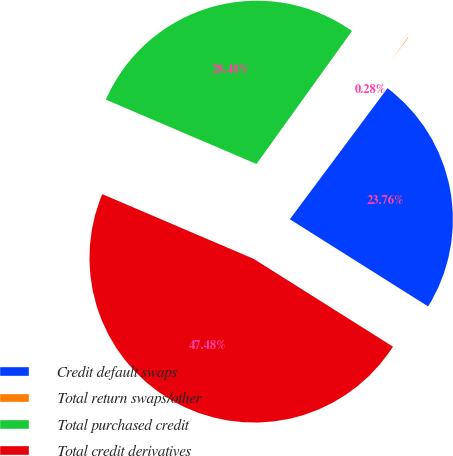Convert chart to OTSL. <chart><loc_0><loc_0><loc_500><loc_500><pie_chart><fcel>Credit default swaps<fcel>Total return swaps/other<fcel>Total purchased credit<fcel>Total credit derivatives<nl><fcel>23.76%<fcel>0.28%<fcel>28.48%<fcel>47.48%<nl></chart> 